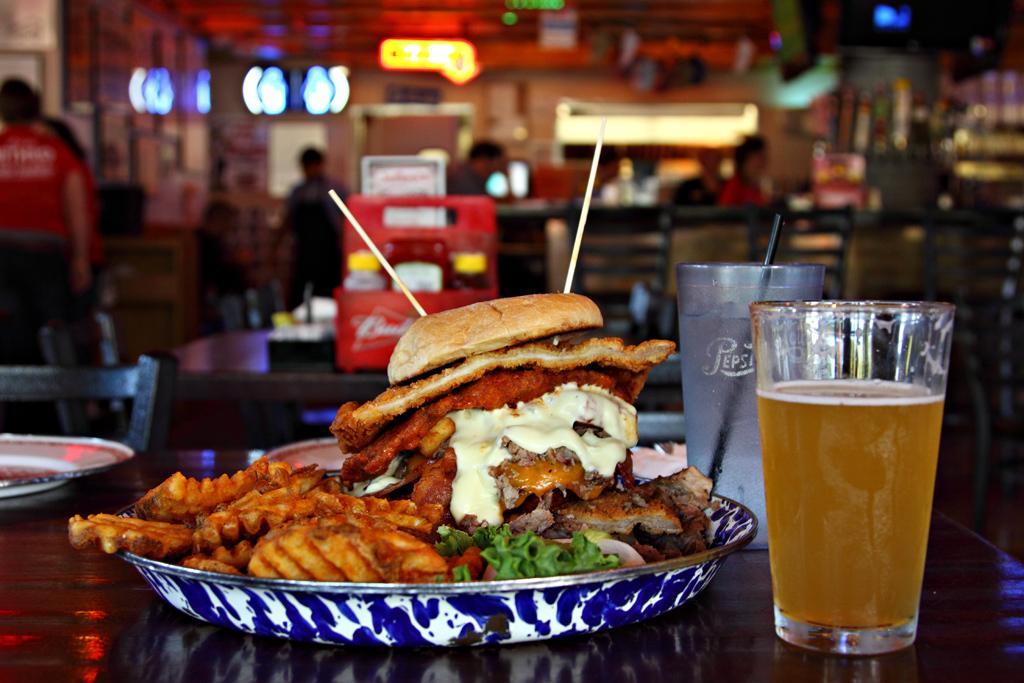Can you describe this image briefly? In this image I can see there is some food placed on the plate and there is a beverage and a wine glass placed on the right side. In the backdrop, I can see there are a few chairs, tables, objects, persons and there are lights attached to the ceiling. 